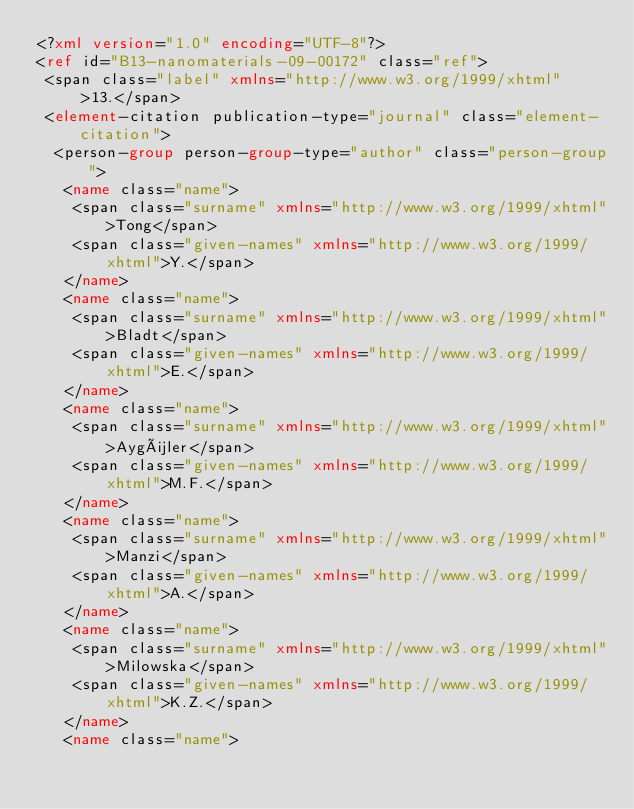Convert code to text. <code><loc_0><loc_0><loc_500><loc_500><_XML_><?xml version="1.0" encoding="UTF-8"?>
<ref id="B13-nanomaterials-09-00172" class="ref">
 <span class="label" xmlns="http://www.w3.org/1999/xhtml">13.</span>
 <element-citation publication-type="journal" class="element-citation">
  <person-group person-group-type="author" class="person-group">
   <name class="name">
    <span class="surname" xmlns="http://www.w3.org/1999/xhtml">Tong</span>
    <span class="given-names" xmlns="http://www.w3.org/1999/xhtml">Y.</span>
   </name>
   <name class="name">
    <span class="surname" xmlns="http://www.w3.org/1999/xhtml">Bladt</span>
    <span class="given-names" xmlns="http://www.w3.org/1999/xhtml">E.</span>
   </name>
   <name class="name">
    <span class="surname" xmlns="http://www.w3.org/1999/xhtml">Aygüler</span>
    <span class="given-names" xmlns="http://www.w3.org/1999/xhtml">M.F.</span>
   </name>
   <name class="name">
    <span class="surname" xmlns="http://www.w3.org/1999/xhtml">Manzi</span>
    <span class="given-names" xmlns="http://www.w3.org/1999/xhtml">A.</span>
   </name>
   <name class="name">
    <span class="surname" xmlns="http://www.w3.org/1999/xhtml">Milowska</span>
    <span class="given-names" xmlns="http://www.w3.org/1999/xhtml">K.Z.</span>
   </name>
   <name class="name"></code> 